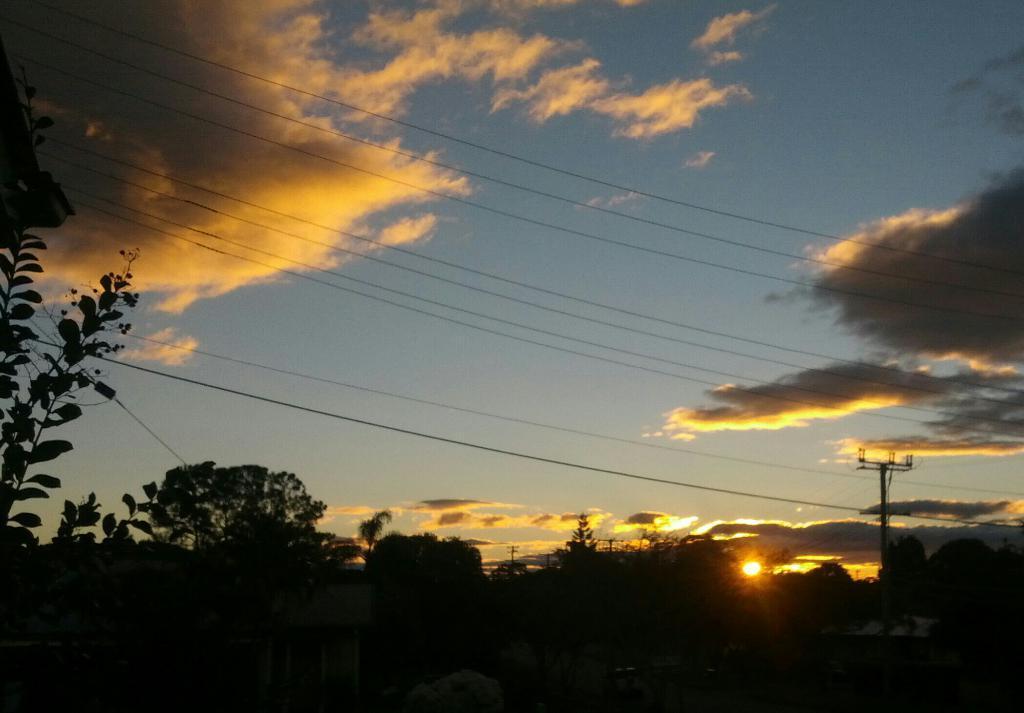Can you describe this image briefly? In this image I can see few trees. In the background I can see few electric poles and the sun is in orange and yellow color and the sky is in white and blue color. 